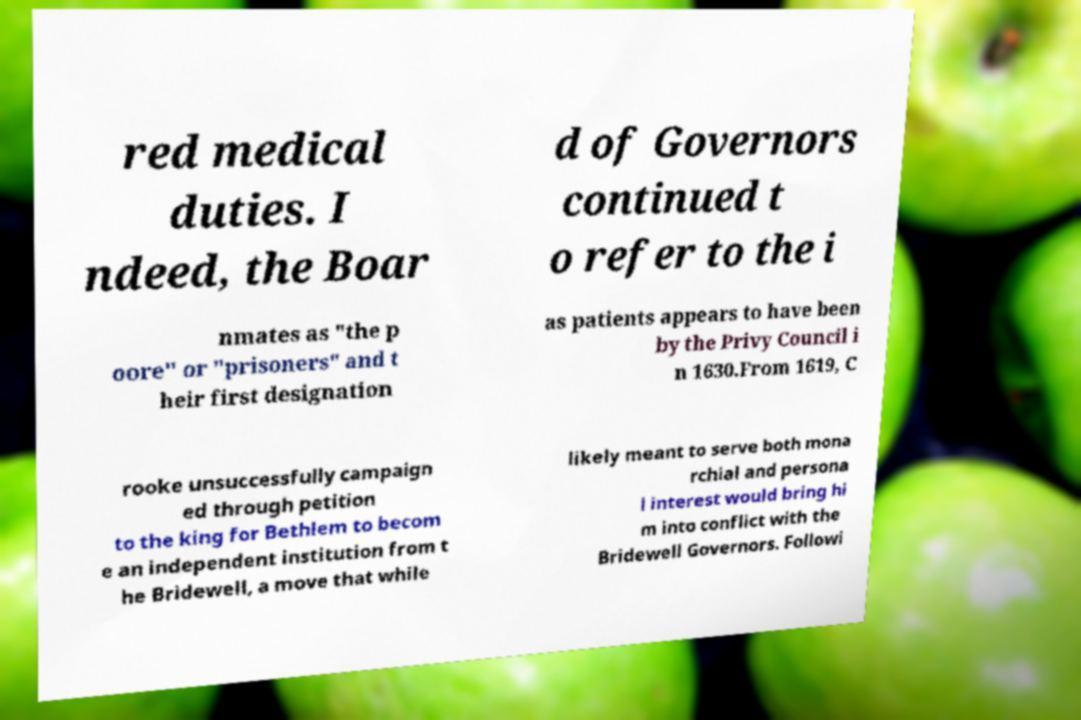What messages or text are displayed in this image? I need them in a readable, typed format. red medical duties. I ndeed, the Boar d of Governors continued t o refer to the i nmates as "the p oore" or "prisoners" and t heir first designation as patients appears to have been by the Privy Council i n 1630.From 1619, C rooke unsuccessfully campaign ed through petition to the king for Bethlem to becom e an independent institution from t he Bridewell, a move that while likely meant to serve both mona rchial and persona l interest would bring hi m into conflict with the Bridewell Governors. Followi 